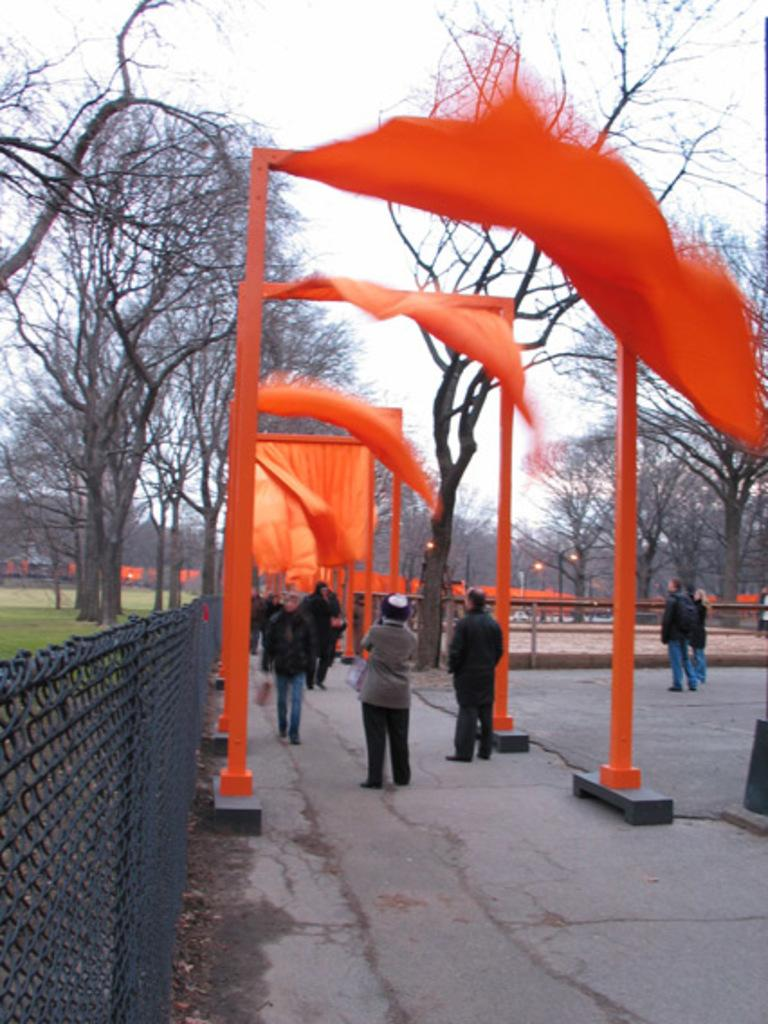What are the people in the image doing? There are people standing and walking in the image. What can be seen on the left side of the image? There is black color fencing on the left side of the image. What type of vegetation is visible in the image? There are trees visible in the image. What is visible at the top of the image? The sky is visible at the top of the image. Can you describe the texture of the grass in the image? There is no grass present in the image; it features black color fencing and trees. What color are the toes of the people walking in the image? The image does not show the people's toes, so it cannot be determined from the picture. 